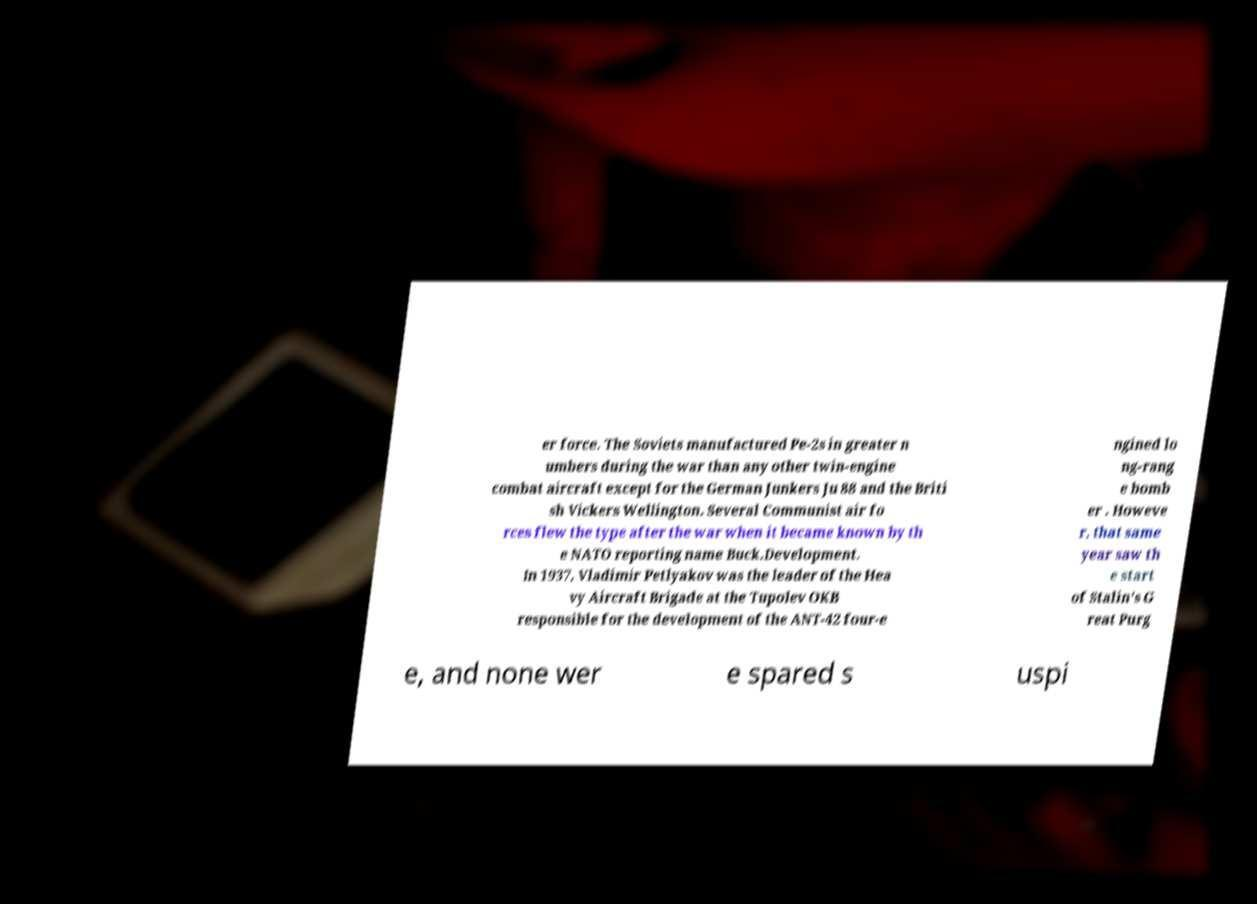Please identify and transcribe the text found in this image. er force. The Soviets manufactured Pe-2s in greater n umbers during the war than any other twin-engine combat aircraft except for the German Junkers Ju 88 and the Briti sh Vickers Wellington. Several Communist air fo rces flew the type after the war when it became known by th e NATO reporting name Buck.Development. In 1937, Vladimir Petlyakov was the leader of the Hea vy Aircraft Brigade at the Tupolev OKB responsible for the development of the ANT-42 four-e ngined lo ng-rang e bomb er . Howeve r, that same year saw th e start of Stalin's G reat Purg e, and none wer e spared s uspi 